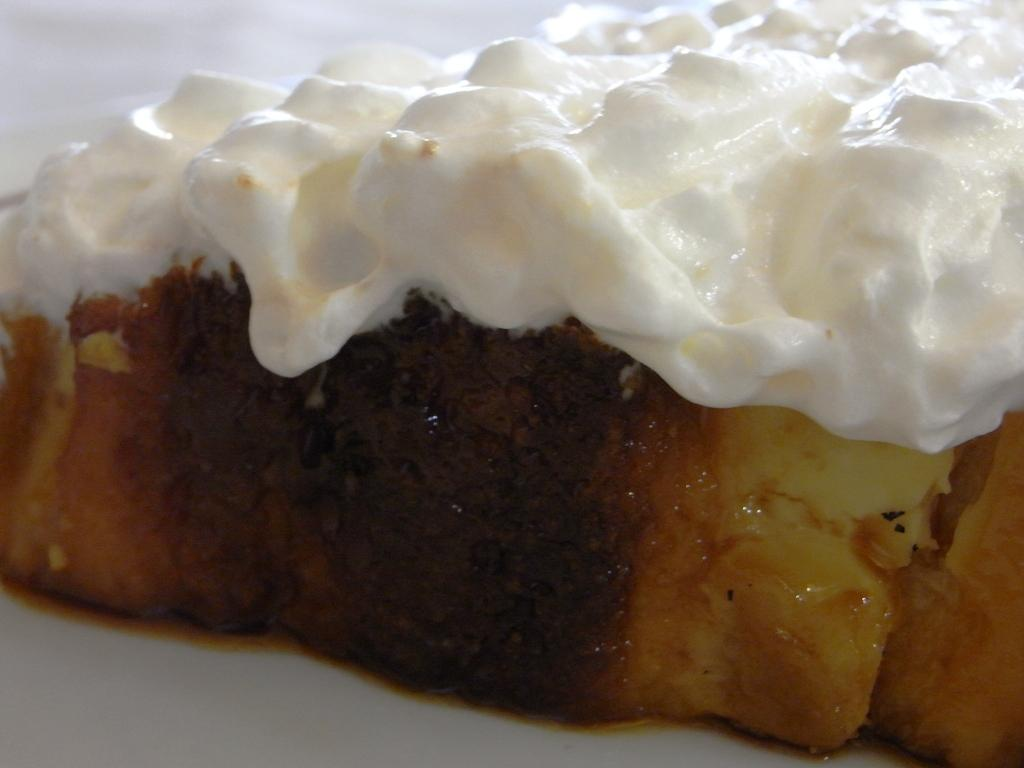What type of food can be seen in the image? There is food in the image, but the specific type is not mentioned. Can you describe any specific ingredient or component of the food? Yes, there is cream in white color in the image. How does the flock of birds interact with the cream in the image? There are no birds, let alone a flock of birds, present in the image. The focus is on the food and cream mentioned in the facts. 